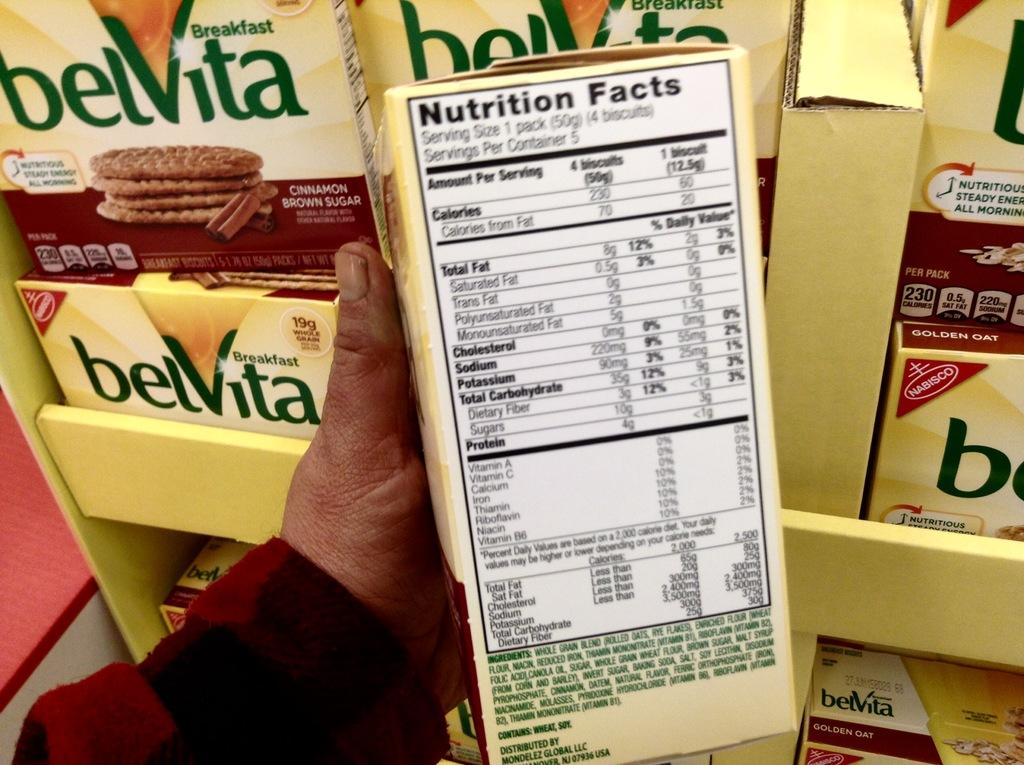What meal is this item intended to be consumed for?
Your answer should be compact. Breakfast. Do four belvita's have 35 carbs in them?
Provide a short and direct response. Yes. 